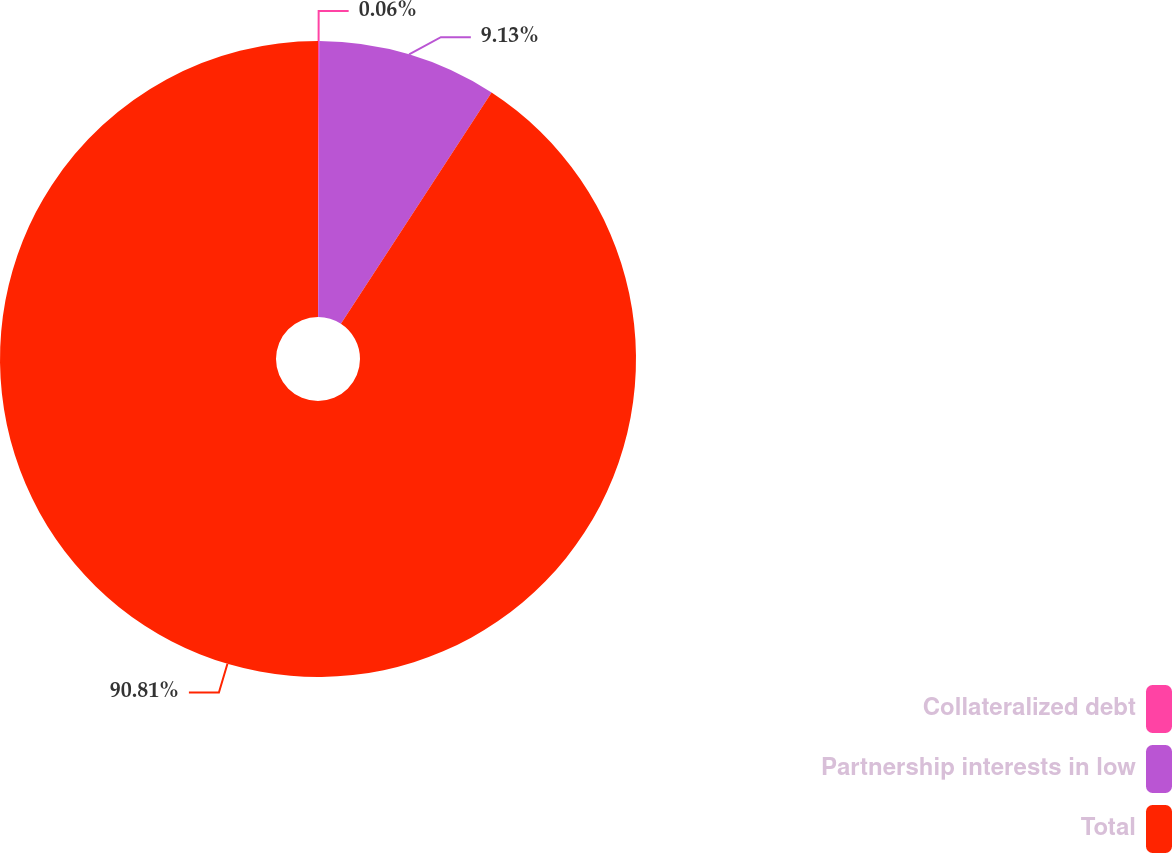Convert chart. <chart><loc_0><loc_0><loc_500><loc_500><pie_chart><fcel>Collateralized debt<fcel>Partnership interests in low<fcel>Total<nl><fcel>0.06%<fcel>9.13%<fcel>90.8%<nl></chart> 